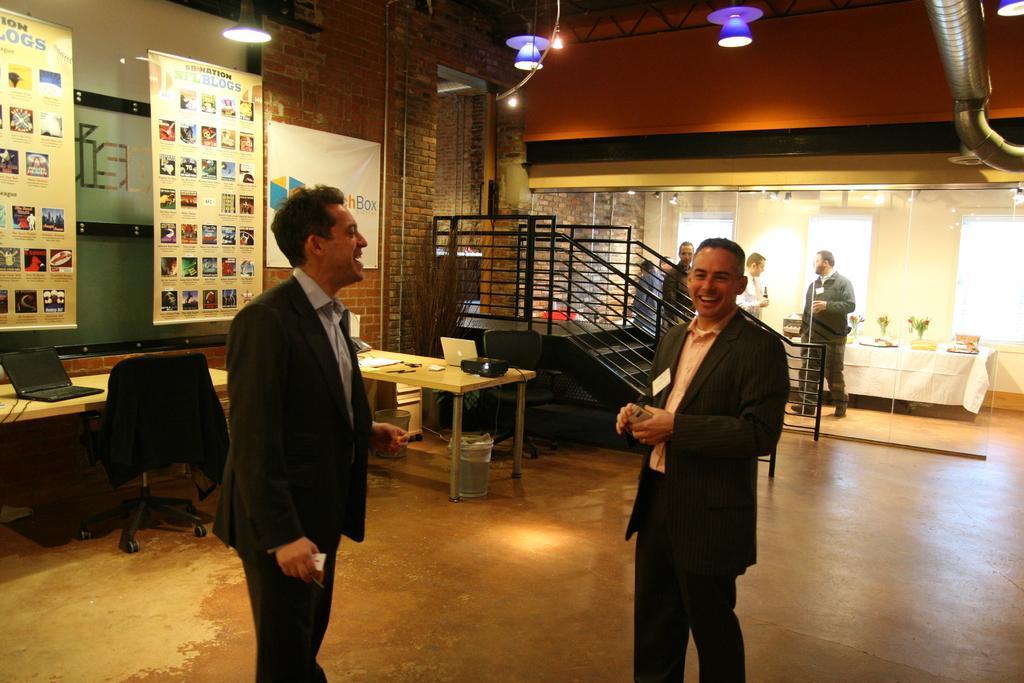Could you give a brief overview of what you see in this image? There are two men standing and smiling in front of each other on the floor. Behind them there is a chair and a table on which a laptop was placed. There are two charts hanged here. In the background there is a railing and some people was standing here. 